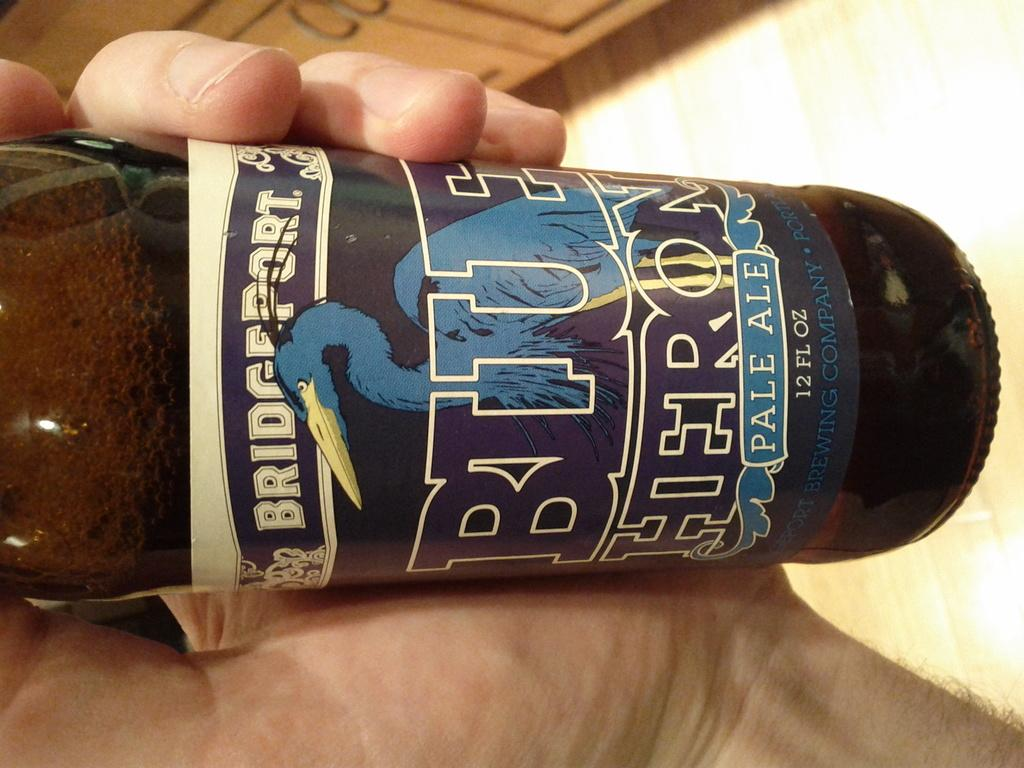<image>
Give a short and clear explanation of the subsequent image. A beer called Blue Heron being held in a hand. 